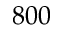<formula> <loc_0><loc_0><loc_500><loc_500>8 0 0</formula> 